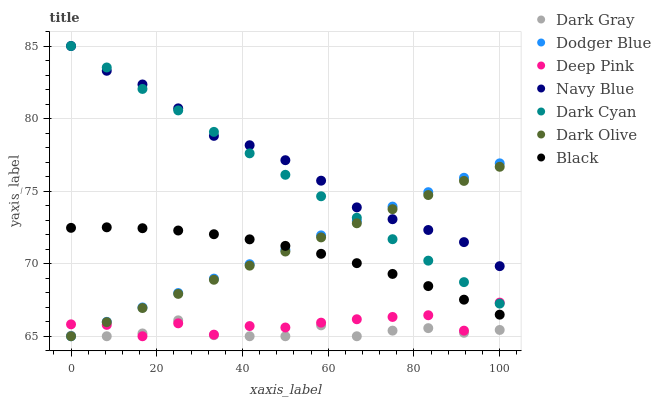Does Dark Gray have the minimum area under the curve?
Answer yes or no. Yes. Does Navy Blue have the maximum area under the curve?
Answer yes or no. Yes. Does Dark Olive have the minimum area under the curve?
Answer yes or no. No. Does Dark Olive have the maximum area under the curve?
Answer yes or no. No. Is Dark Olive the smoothest?
Answer yes or no. Yes. Is Deep Pink the roughest?
Answer yes or no. Yes. Is Navy Blue the smoothest?
Answer yes or no. No. Is Navy Blue the roughest?
Answer yes or no. No. Does Deep Pink have the lowest value?
Answer yes or no. Yes. Does Navy Blue have the lowest value?
Answer yes or no. No. Does Dark Cyan have the highest value?
Answer yes or no. Yes. Does Dark Olive have the highest value?
Answer yes or no. No. Is Black less than Dark Cyan?
Answer yes or no. Yes. Is Black greater than Dark Gray?
Answer yes or no. Yes. Does Dark Olive intersect Dark Cyan?
Answer yes or no. Yes. Is Dark Olive less than Dark Cyan?
Answer yes or no. No. Is Dark Olive greater than Dark Cyan?
Answer yes or no. No. Does Black intersect Dark Cyan?
Answer yes or no. No. 